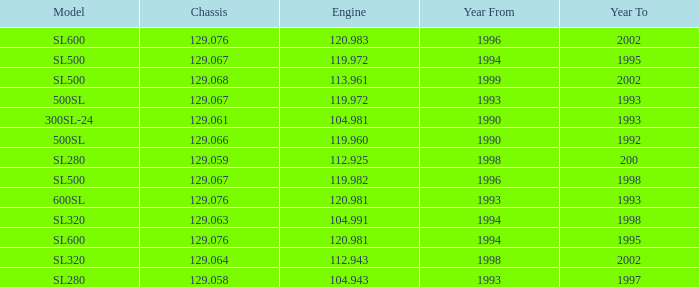Which Engine has a Model of sl500, and a Year From larger than 1999? None. Would you be able to parse every entry in this table? {'header': ['Model', 'Chassis', 'Engine', 'Year From', 'Year To'], 'rows': [['SL600', '129.076', '120.983', '1996', '2002'], ['SL500', '129.067', '119.972', '1994', '1995'], ['SL500', '129.068', '113.961', '1999', '2002'], ['500SL', '129.067', '119.972', '1993', '1993'], ['300SL-24', '129.061', '104.981', '1990', '1993'], ['500SL', '129.066', '119.960', '1990', '1992'], ['SL280', '129.059', '112.925', '1998', '200'], ['SL500', '129.067', '119.982', '1996', '1998'], ['600SL', '129.076', '120.981', '1993', '1993'], ['SL320', '129.063', '104.991', '1994', '1998'], ['SL600', '129.076', '120.981', '1994', '1995'], ['SL320', '129.064', '112.943', '1998', '2002'], ['SL280', '129.058', '104.943', '1993', '1997']]} 